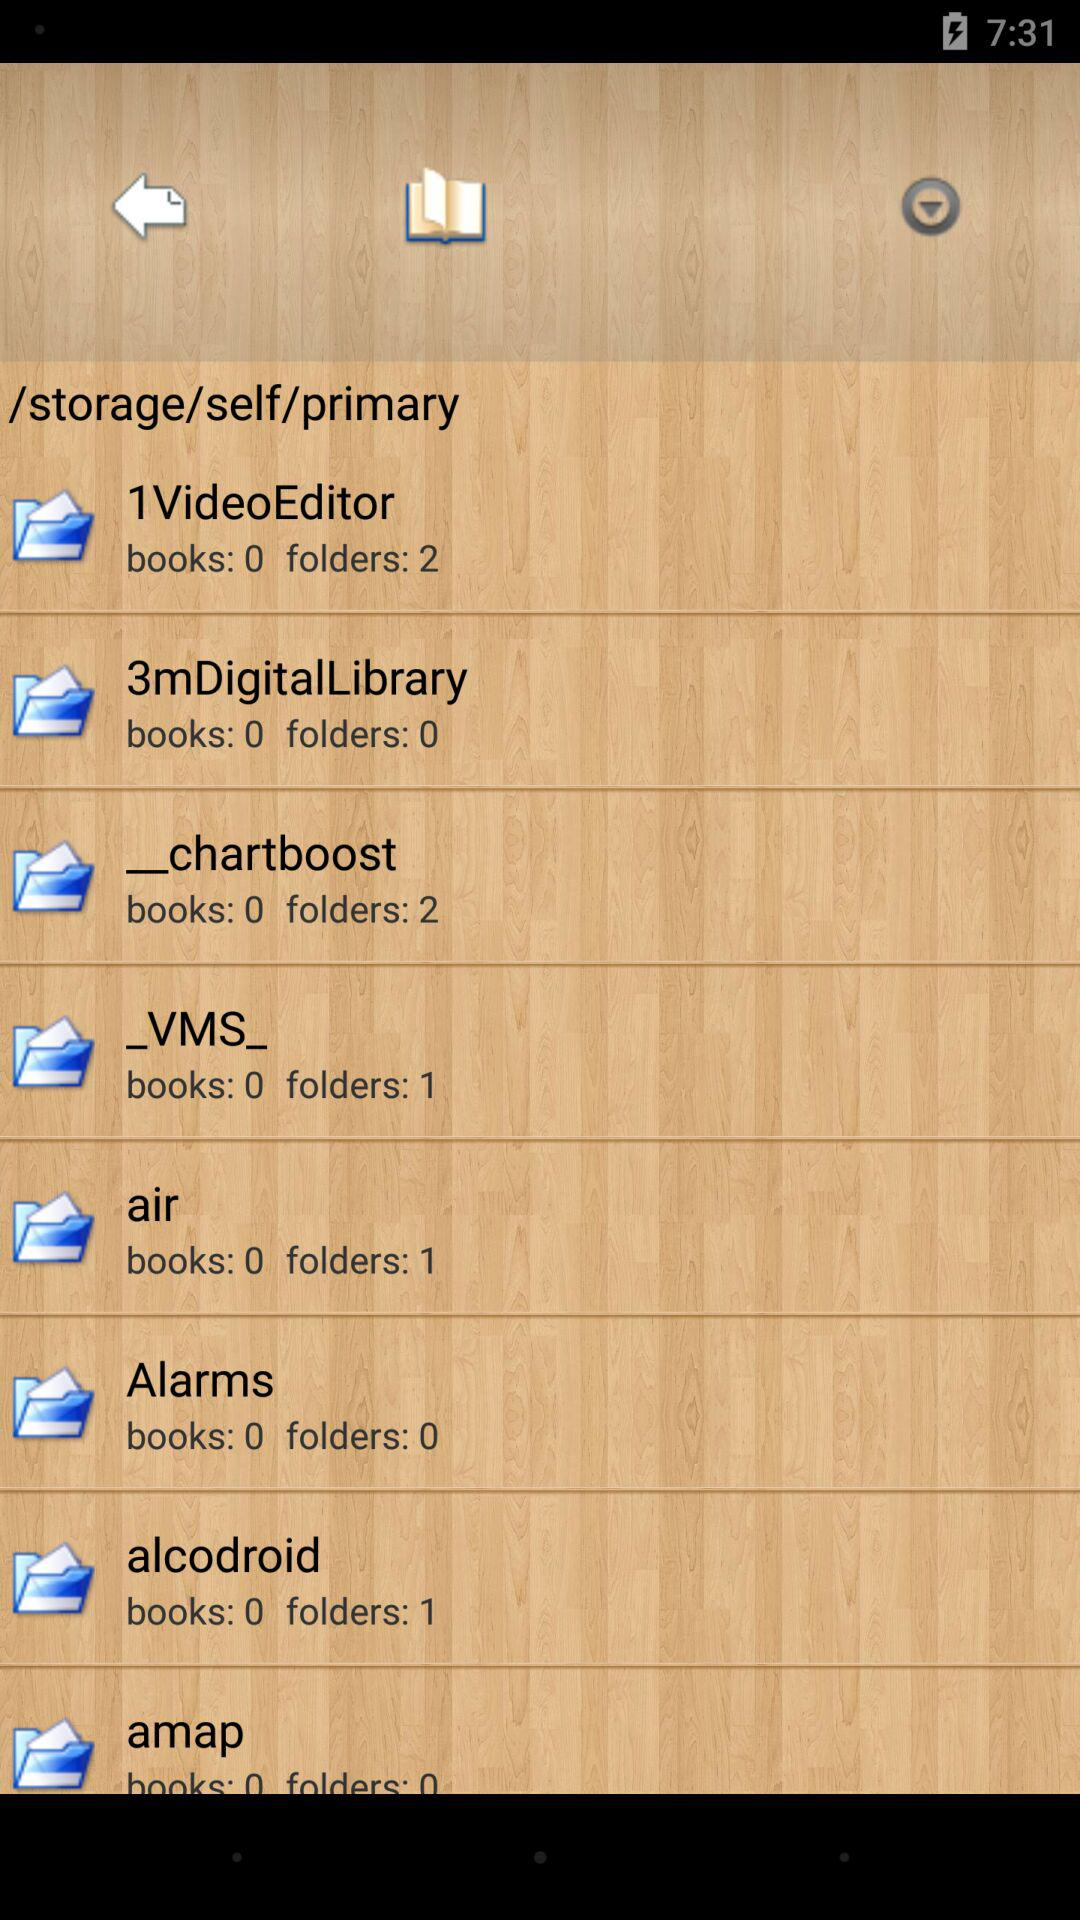How many folders are there in "alcodroid"? There is 1 folder in "alcodroid". 